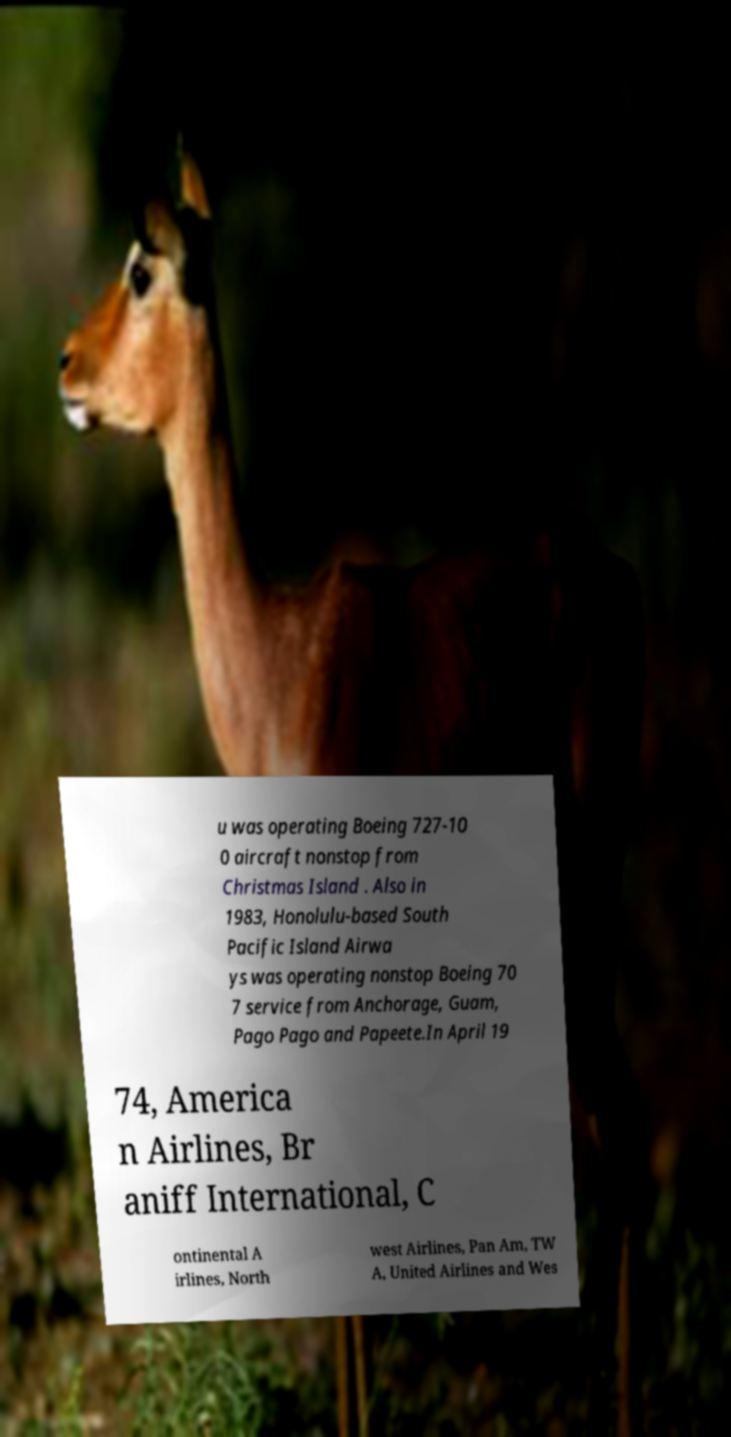Can you read and provide the text displayed in the image?This photo seems to have some interesting text. Can you extract and type it out for me? u was operating Boeing 727-10 0 aircraft nonstop from Christmas Island . Also in 1983, Honolulu-based South Pacific Island Airwa ys was operating nonstop Boeing 70 7 service from Anchorage, Guam, Pago Pago and Papeete.In April 19 74, America n Airlines, Br aniff International, C ontinental A irlines, North west Airlines, Pan Am, TW A, United Airlines and Wes 